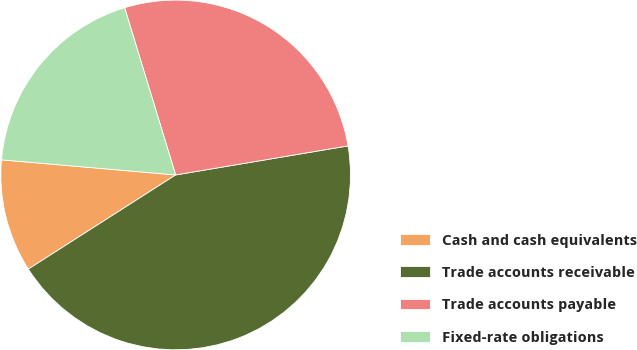<chart> <loc_0><loc_0><loc_500><loc_500><pie_chart><fcel>Cash and cash equivalents<fcel>Trade accounts receivable<fcel>Trade accounts payable<fcel>Fixed-rate obligations<nl><fcel>10.43%<fcel>43.61%<fcel>27.06%<fcel>18.91%<nl></chart> 